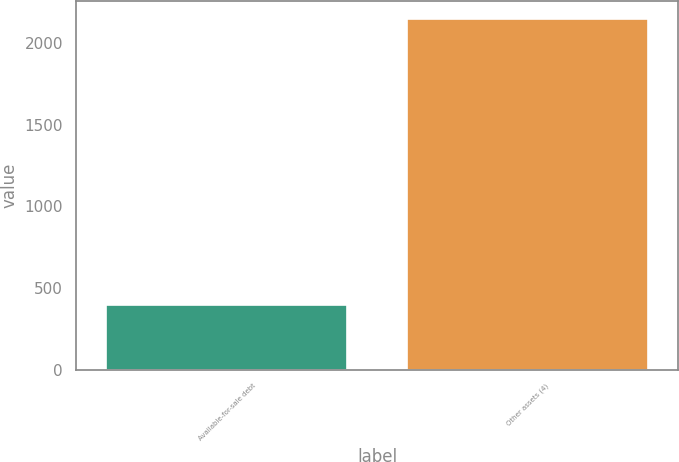<chart> <loc_0><loc_0><loc_500><loc_500><bar_chart><fcel>Available-for-sale debt<fcel>Other assets (4)<nl><fcel>398<fcel>2149<nl></chart> 